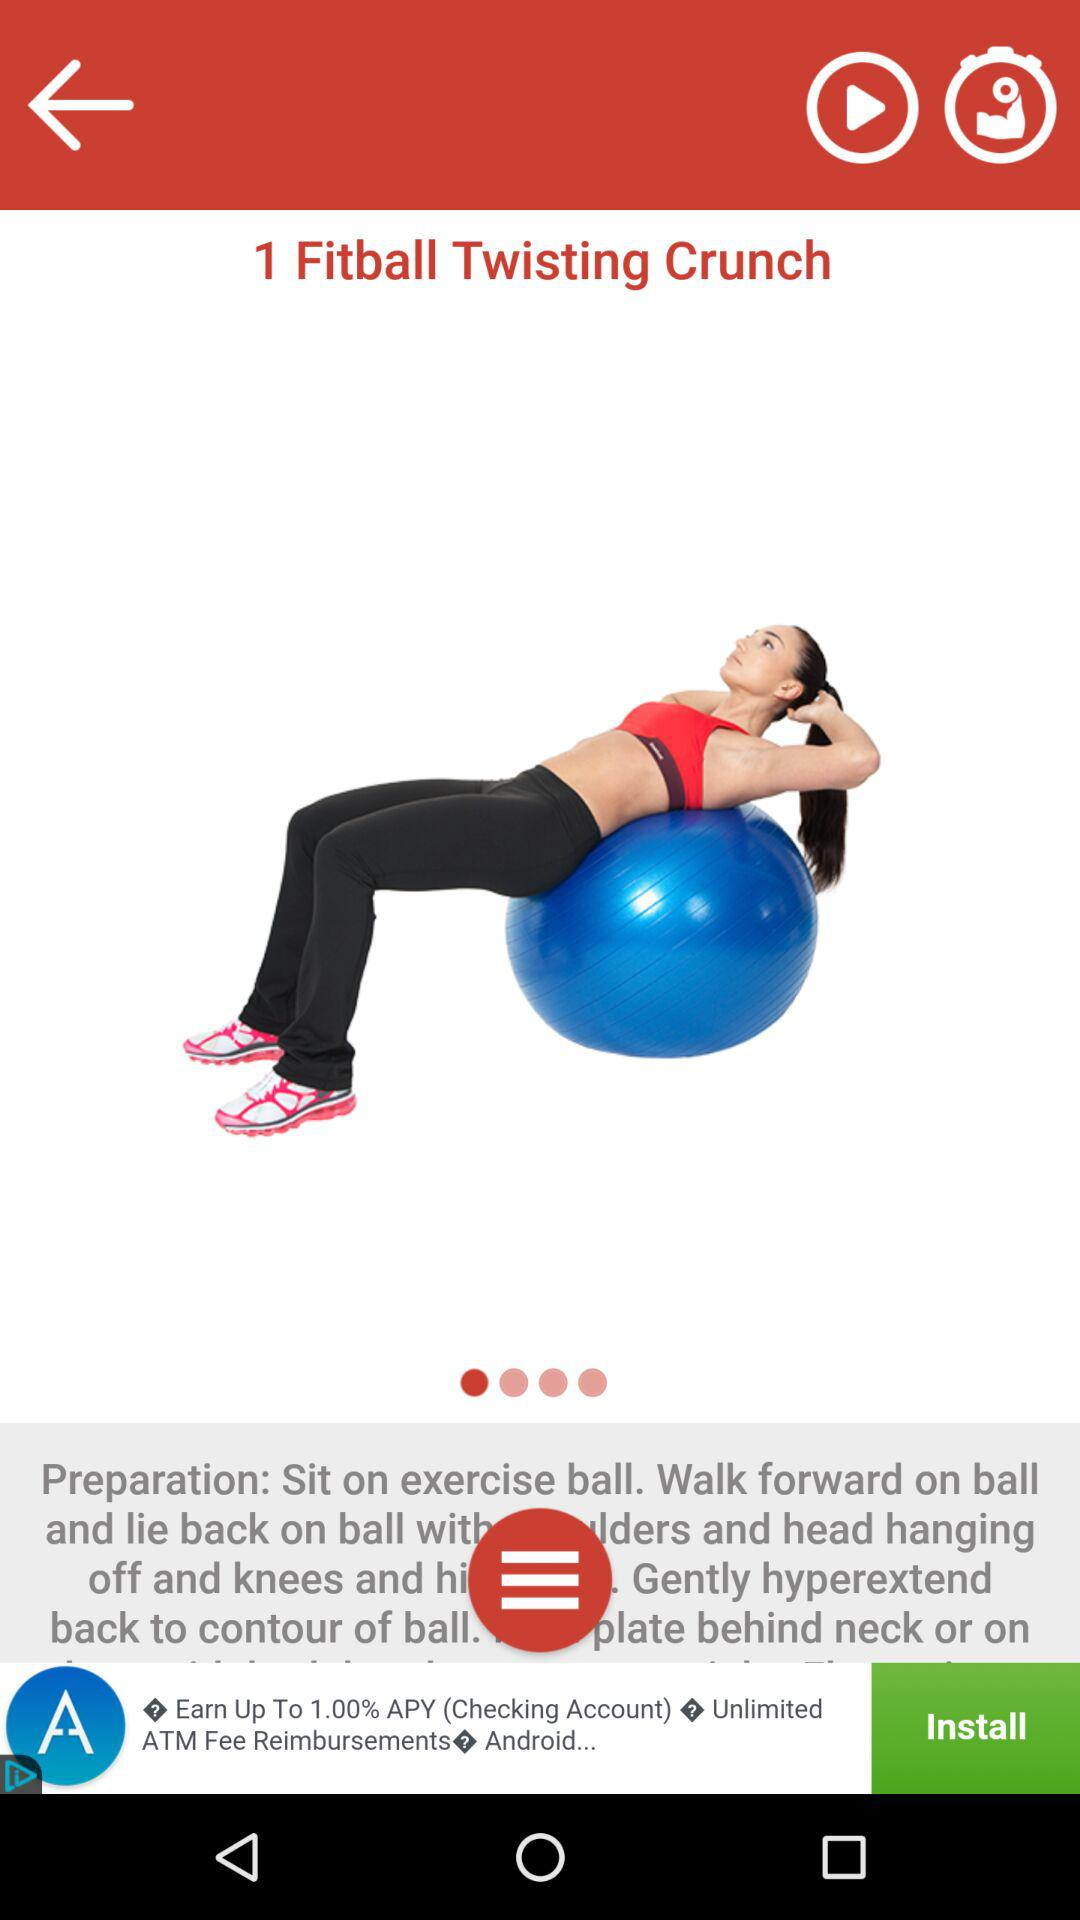What is the Fit ball Twisting Crunch?
When the provided information is insufficient, respond with <no answer>. <no answer> 